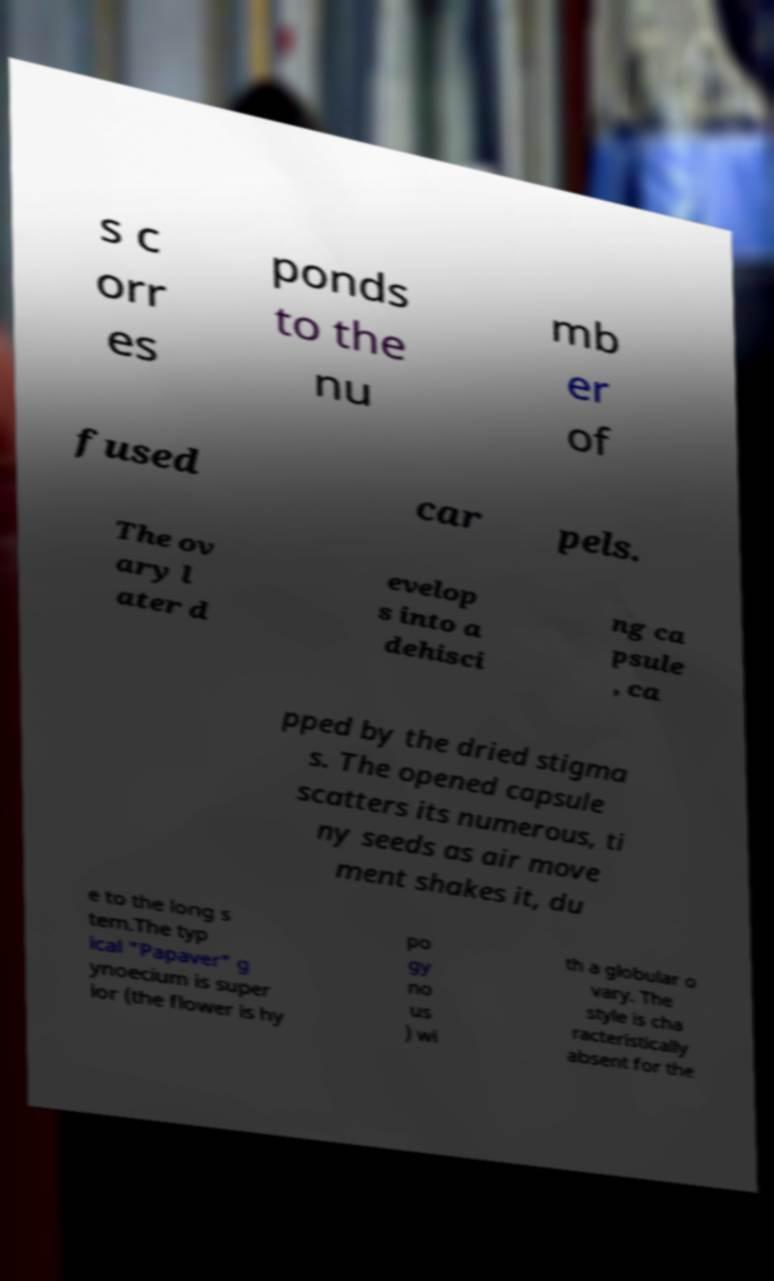I need the written content from this picture converted into text. Can you do that? s c orr es ponds to the nu mb er of fused car pels. The ov ary l ater d evelop s into a dehisci ng ca psule , ca pped by the dried stigma s. The opened capsule scatters its numerous, ti ny seeds as air move ment shakes it, du e to the long s tem.The typ ical "Papaver" g ynoecium is super ior (the flower is hy po gy no us ) wi th a globular o vary. The style is cha racteristically absent for the 